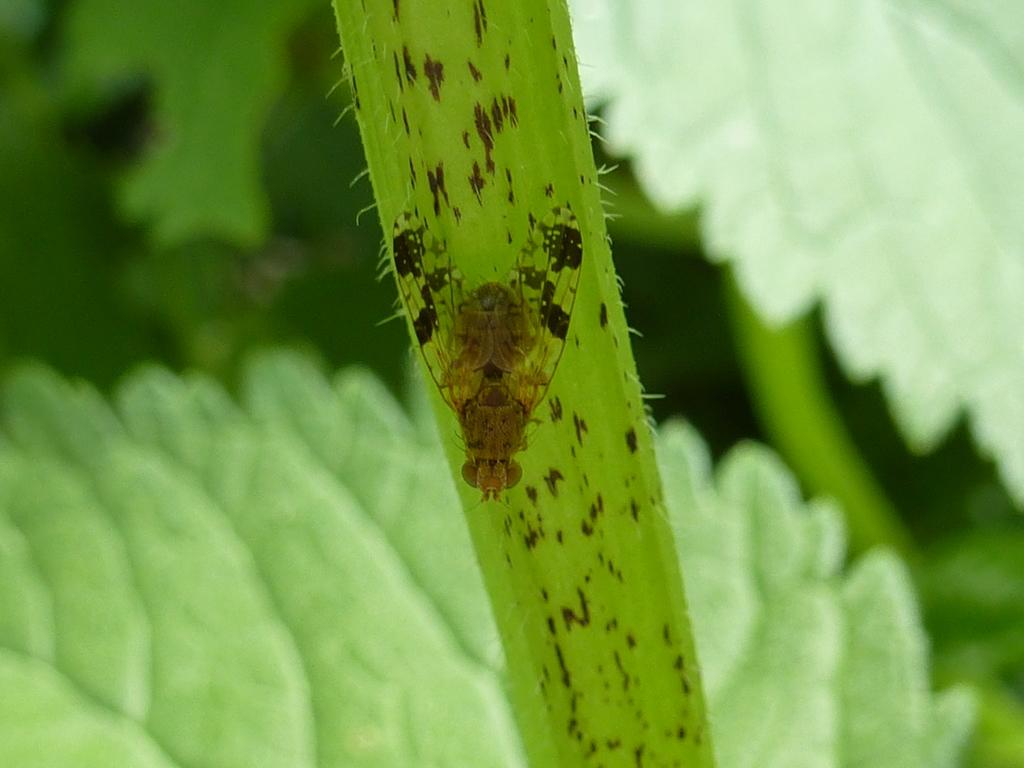What is the main subject of the image? There is an insect on a leaf in the image. What can be seen in the background of the image? The background of the image is green. What rhythm is the insect playing on the leaf in the image? There is no indication in the image that the insect is playing a rhythm or making any sounds. 